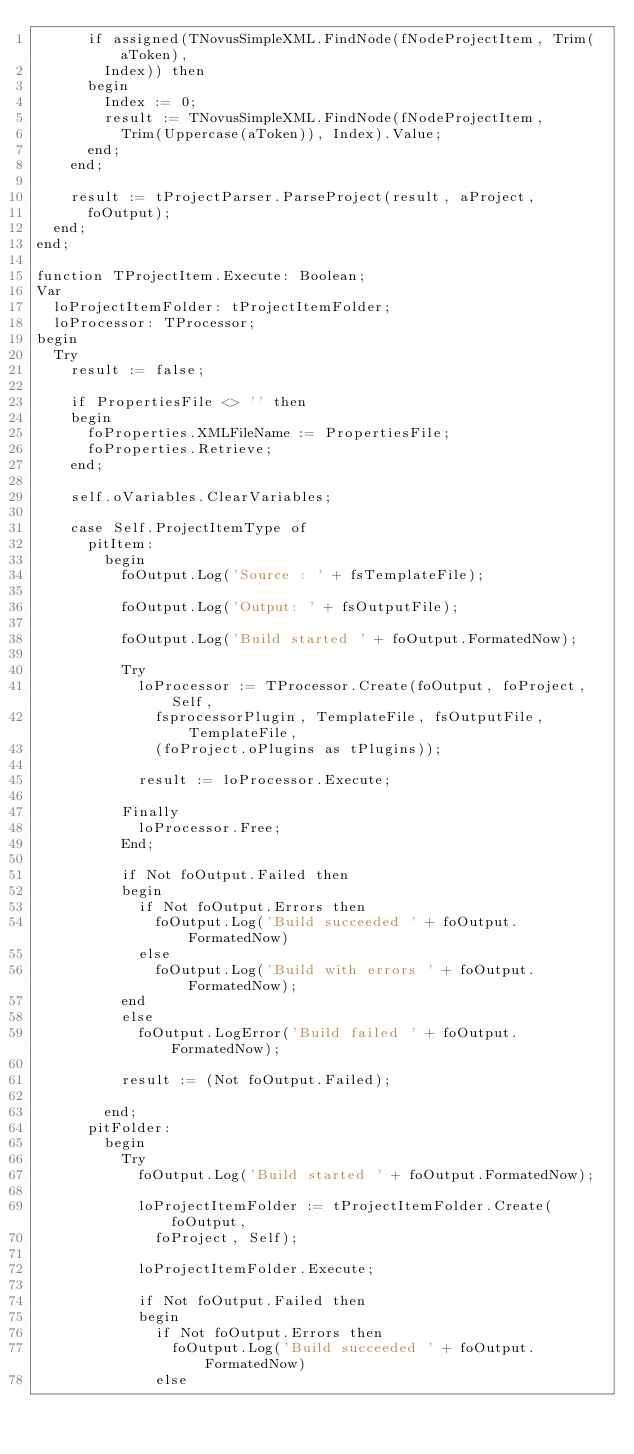Convert code to text. <code><loc_0><loc_0><loc_500><loc_500><_Pascal_>      if assigned(TNovusSimpleXML.FindNode(fNodeProjectItem, Trim(aToken),
        Index)) then
      begin
        Index := 0;
        result := TNovusSimpleXML.FindNode(fNodeProjectItem,
          Trim(Uppercase(aToken)), Index).Value;
      end;
    end;

    result := tProjectParser.ParseProject(result, aProject,
      foOutput);
  end;
end;

function TProjectItem.Execute: Boolean;
Var
  loProjectItemFolder: tProjectItemFolder;
  loProcessor: TProcessor;
begin
  Try
    result := false;

    if PropertiesFile <> '' then
    begin
      foProperties.XMLFileName := PropertiesFile;
      foProperties.Retrieve;
    end;

    self.oVariables.ClearVariables;

    case Self.ProjectItemType of
      pitItem:
        begin
          foOutput.Log('Source : ' + fsTemplateFile);

          foOutput.Log('Output: ' + fsOutputFile);

          foOutput.Log('Build started ' + foOutput.FormatedNow);

          Try
            loProcessor := TProcessor.Create(foOutput, foProject, Self,
              fsprocessorPlugin, TemplateFile, fsOutputFile, TemplateFile,
              (foProject.oPlugins as tPlugins));

            result := loProcessor.Execute;

          Finally
            loProcessor.Free;
          End;

          if Not foOutput.Failed then
          begin
            if Not foOutput.Errors then
              foOutput.Log('Build succeeded ' + foOutput.FormatedNow)
            else
              foOutput.Log('Build with errors ' + foOutput.FormatedNow);
          end
          else
            foOutput.LogError('Build failed ' + foOutput.FormatedNow);

          result := (Not foOutput.Failed);

        end;
      pitFolder:
        begin
          Try
            foOutput.Log('Build started ' + foOutput.FormatedNow);

            loProjectItemFolder := tProjectItemFolder.Create(foOutput,
              foProject, Self);

            loProjectItemFolder.Execute;

            if Not foOutput.Failed then
            begin
              if Not foOutput.Errors then
                foOutput.Log('Build succeeded ' + foOutput.FormatedNow)
              else</code> 